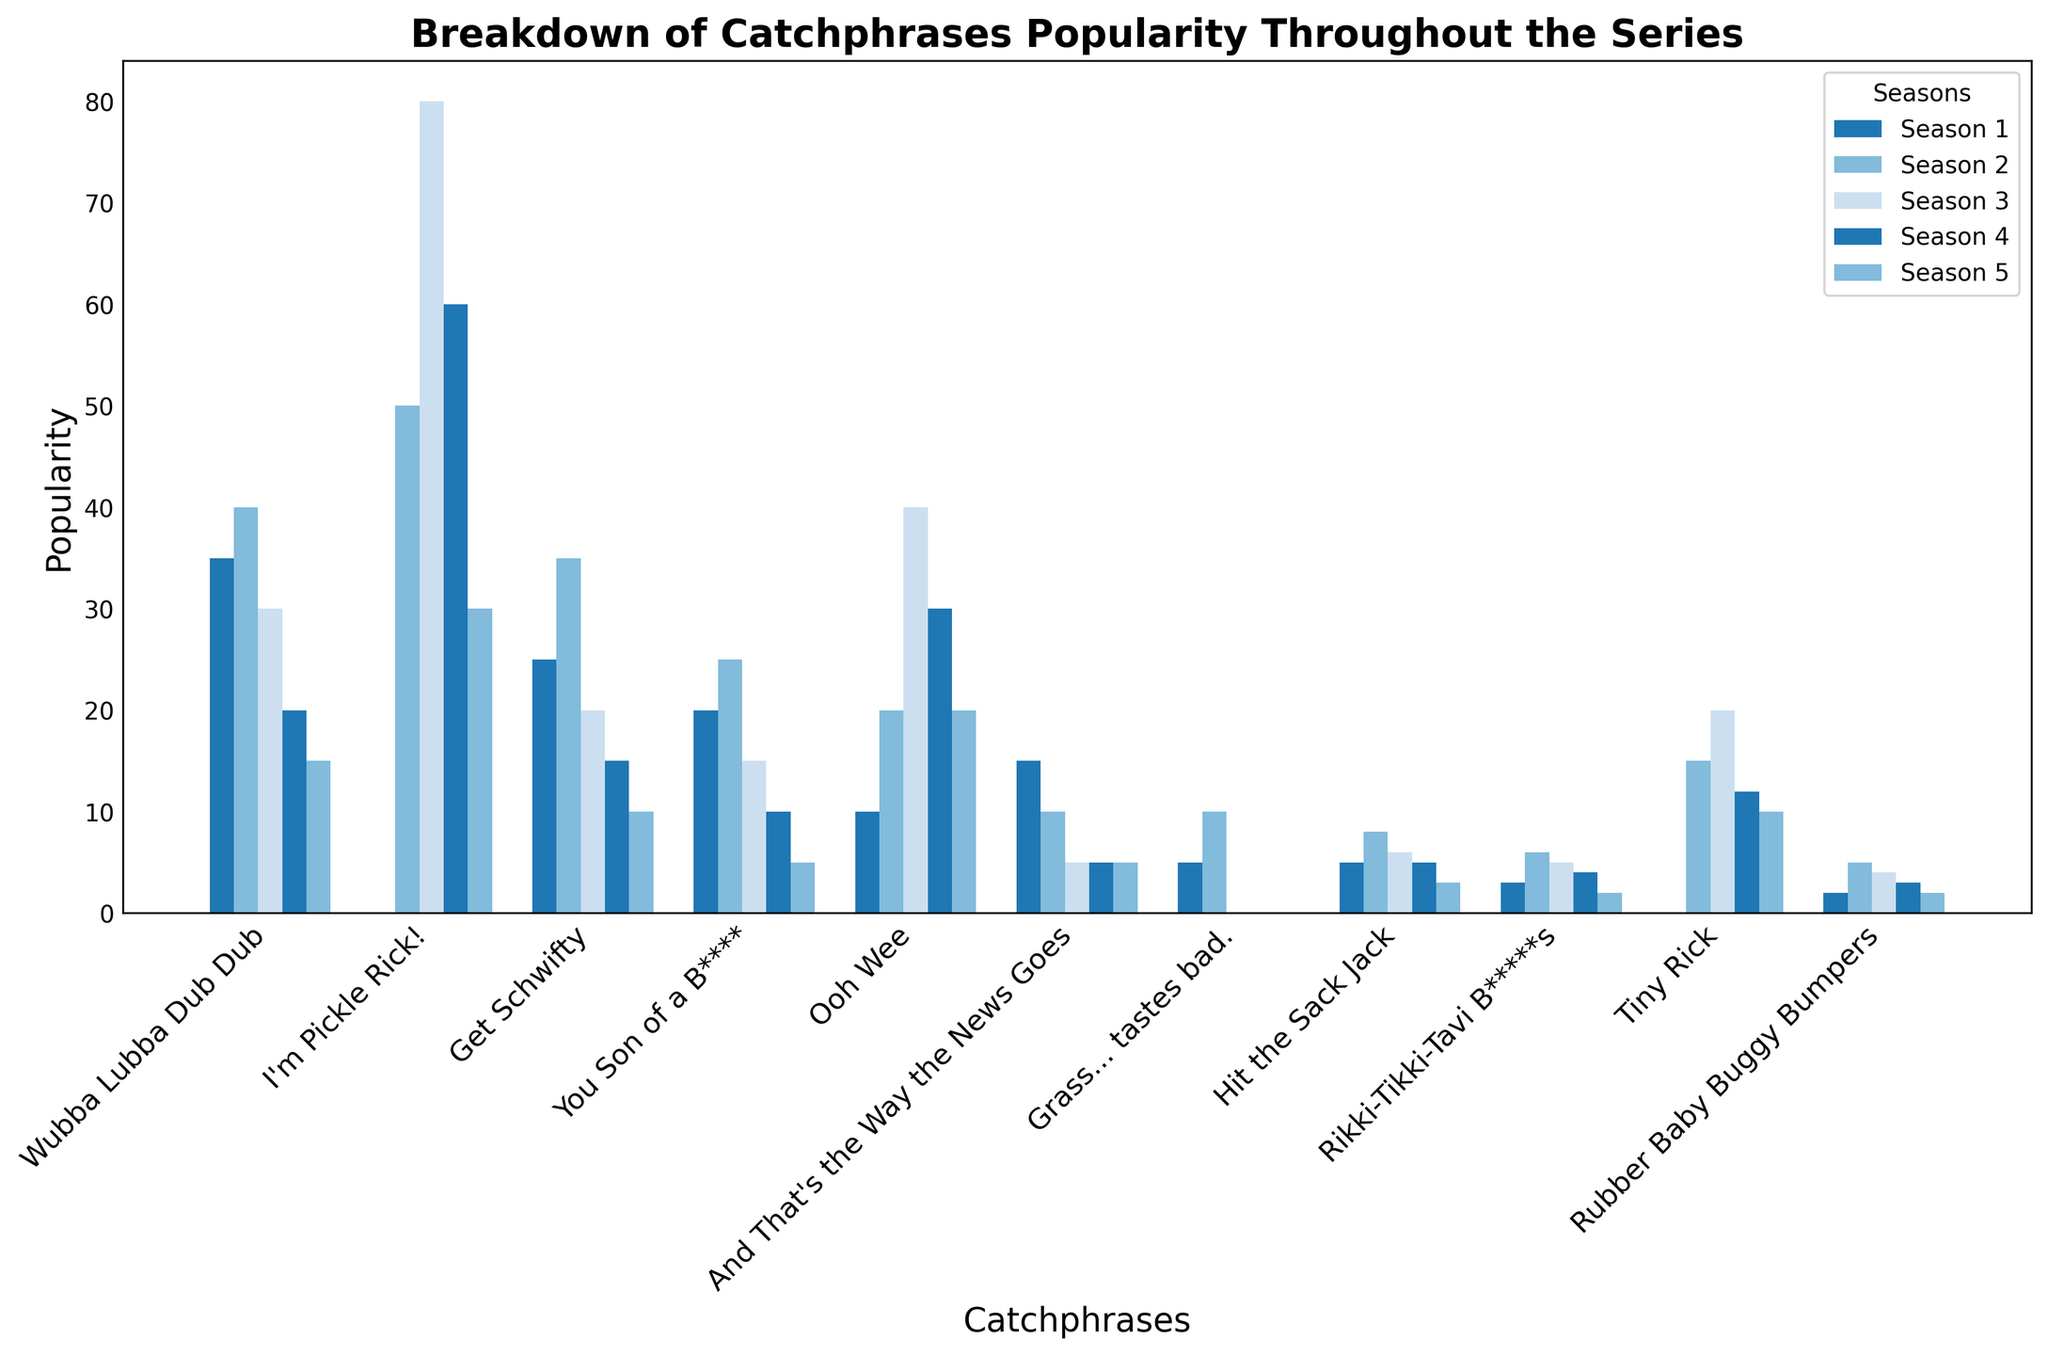Which catchphrase was the most popular in Season 3? By examining the heights of the bars corresponding to Season 3, "I'm Pickle Rick!" has the highest bar, indicating it was the most popular catchphrase in that season.
Answer: "I'm Pickle Rick!" Which catchphrase saw the biggest drop in popularity from Season 2 to Season 3? The catchphrase "Wubba Lubba Dub Dub" decreased from 40 in Season 2 to 30 in Season 3, which is a drop of 10. Examining all other declines, none are larger than this; therefore, it saw the biggest drop.
Answer: "Wubba Lubba Dub Dub" What is the overall trend of the catchphrase "Ooh Wee" from Season 1 to Season 5? To identify the trend, observe the bars for "Ooh Wee" across the seasons: 10 (Season 1), 20 (Season 2), 40 (Season 3), 30 (Season 4), and 20 (Season 5). The popularity increased up to Season 3 and then decreased.
Answer: Increased then decreased Which season had the highest cumulative popularity for all catchphrases combined? Sum the bar heights for each season: Season 1, Season 2, Season 3, Season 4, and Season 5. After calculation, Season 3 has the highest total.
Answer: Season 3 Did "Tiny Rick" debut in Season 1? By examining the bar for "Tiny Rick" in Season 1, which is non-existent (0), it can be inferred that it did not debut in Season 1.
Answer: No Compare the popularity of "Get Schwifty" in Season 1 and Season 5. Which season has a higher popularity? The bar for "Get Schwifty" in Season 1 is higher (25) than in Season 5 (10).
Answer: Season 1 How many catchphrases had increasing popularity from Season 1 to Season 2? By comparing the bar heights, "Wubba Lubba Dub Dub," "Get Schwifty," "You Son of a B****," "Ooh Wee," "And That's the Way the News Goes," "Grass... tastes bad," "Hit the Sack Jack," "Rikki-Tikki-Tavi B****s," "Tiny Rick," and "Rubber Baby Buggy Bumpers" all show increased popularity from Season 1 to Season 2.
Answer: 10 Which catchphrases last saw popularity in Season 5? Examine each catchphrase for a bar height of 0 in Season 5: None of the given catchphrases have a height of 0 in Season 5, meaning no catchphrases last saw popularity exclusively in that season.
Answer: None Which catchphrase had the lowest consistent popularity across all seasons? By examining the bars for all seasons consistently, "Rubber Baby Buggy Bumpers" presents the lowest overall sum across the seasons.
Answer: "Rubber Baby Buggy Bumpers" How many catchphrases have their peak popularity in Season 2? By observing the heights of bars in Season 2 and comparing them with the other seasons, "I'm Pickle Rick!" and "Tiny Rick" reach their peak popularity in Season 2.
Answer: 2 